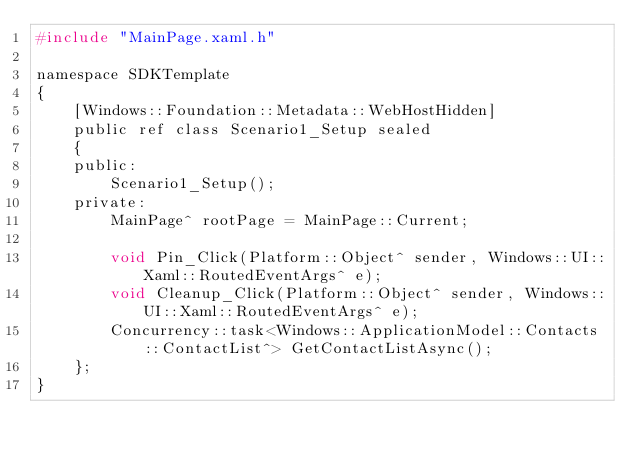<code> <loc_0><loc_0><loc_500><loc_500><_C_>#include "MainPage.xaml.h"

namespace SDKTemplate
{
    [Windows::Foundation::Metadata::WebHostHidden]
    public ref class Scenario1_Setup sealed
    {
    public:
        Scenario1_Setup();
    private:
        MainPage^ rootPage = MainPage::Current;

        void Pin_Click(Platform::Object^ sender, Windows::UI::Xaml::RoutedEventArgs^ e);
        void Cleanup_Click(Platform::Object^ sender, Windows::UI::Xaml::RoutedEventArgs^ e);
        Concurrency::task<Windows::ApplicationModel::Contacts::ContactList^> GetContactListAsync();
    };
}
</code> 